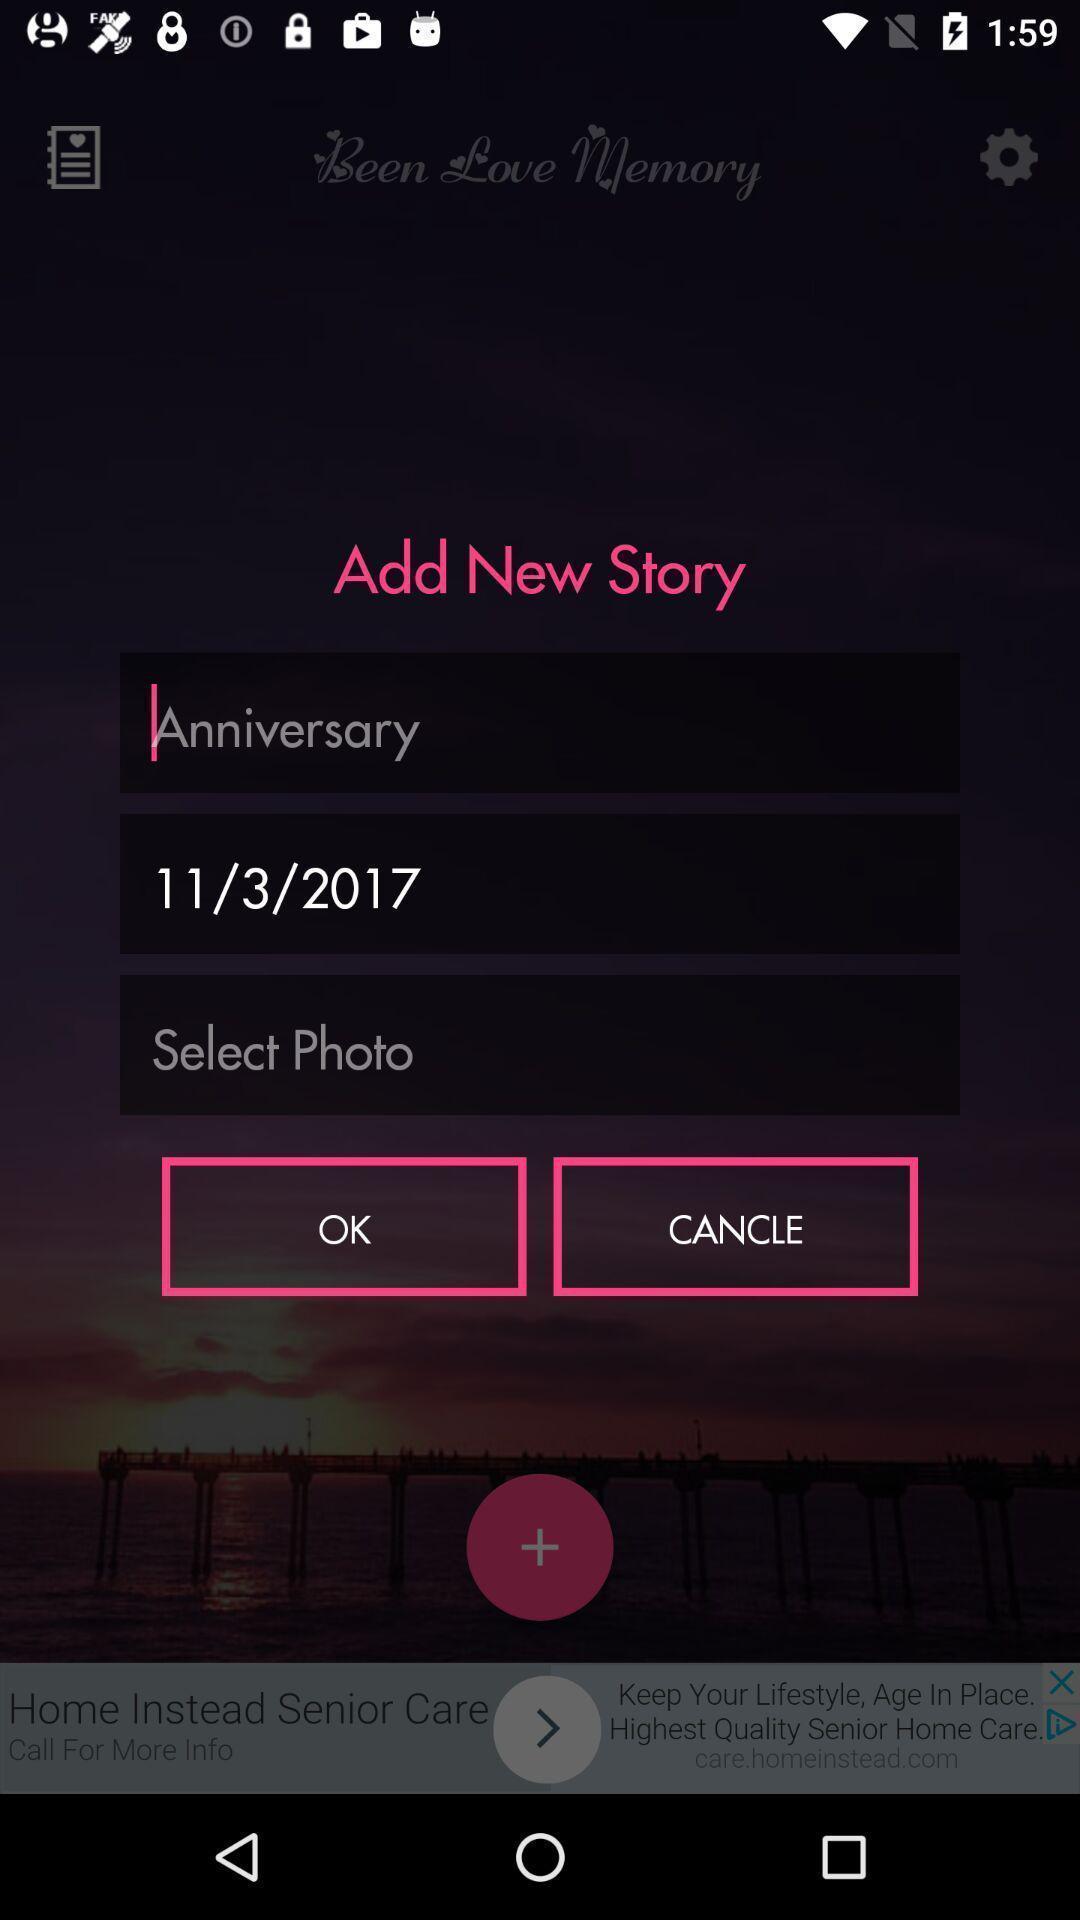Give me a summary of this screen capture. Pop-up displaying to add new story in app. 